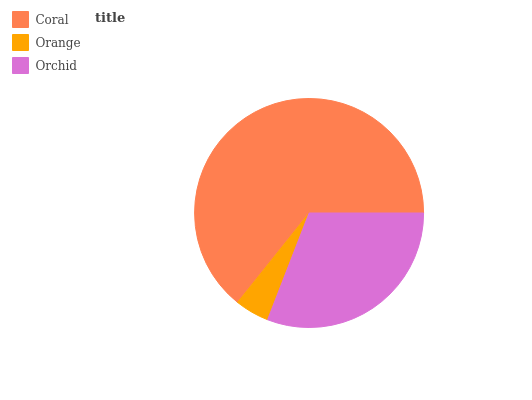Is Orange the minimum?
Answer yes or no. Yes. Is Coral the maximum?
Answer yes or no. Yes. Is Orchid the minimum?
Answer yes or no. No. Is Orchid the maximum?
Answer yes or no. No. Is Orchid greater than Orange?
Answer yes or no. Yes. Is Orange less than Orchid?
Answer yes or no. Yes. Is Orange greater than Orchid?
Answer yes or no. No. Is Orchid less than Orange?
Answer yes or no. No. Is Orchid the high median?
Answer yes or no. Yes. Is Orchid the low median?
Answer yes or no. Yes. Is Orange the high median?
Answer yes or no. No. Is Orange the low median?
Answer yes or no. No. 